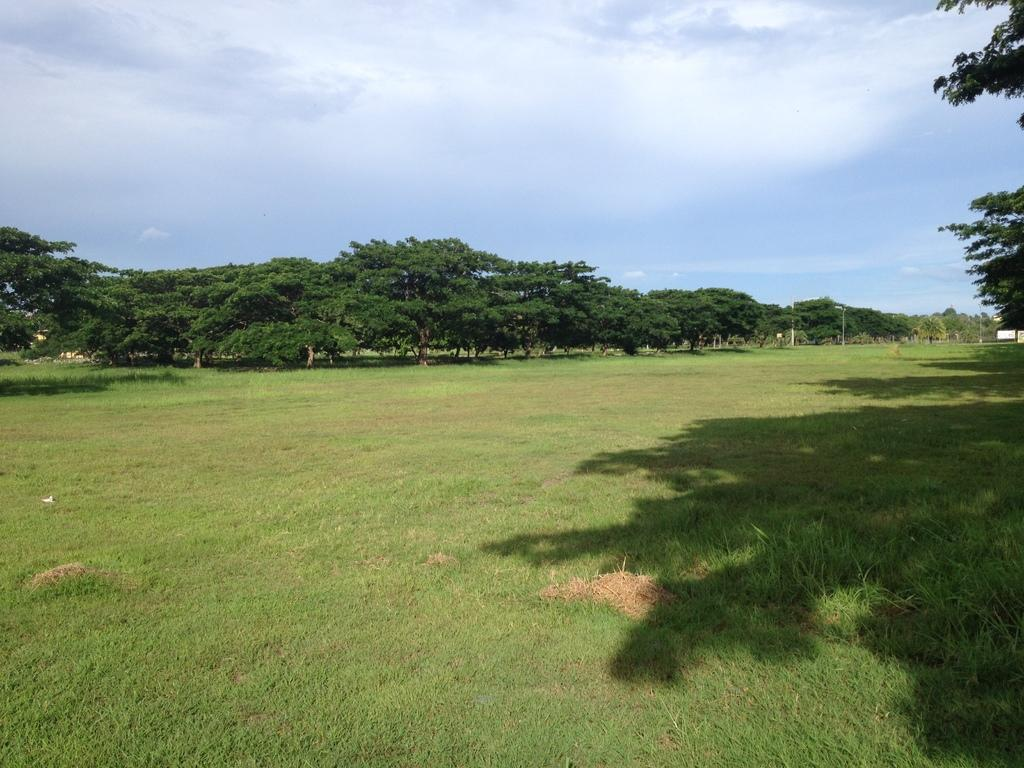What type of vegetation is on the right side of the image? There are leaves on the right side of the image. What type of ground cover is in the center of the image? There is grass on the ground in the center of the image. What can be seen in the background of the image? There are trees in the background of the image. What is the condition of the sky in the image? The sky is cloudy in the image. Is there a basin filled with snow in the image? No, there is no basin or snow present in the image. Can you see any toes in the image? There are no toes visible in the image. 